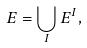<formula> <loc_0><loc_0><loc_500><loc_500>E & = \bigcup _ { I } E ^ { I } ,</formula> 